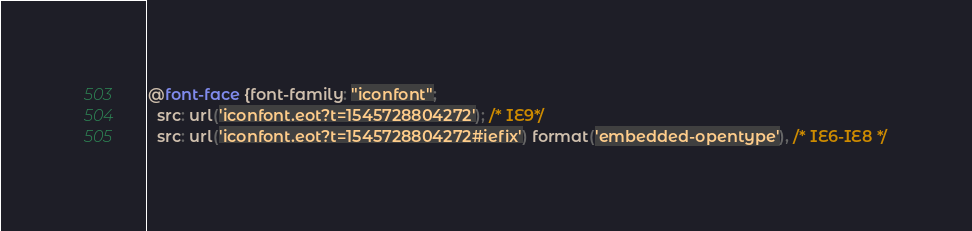<code> <loc_0><loc_0><loc_500><loc_500><_CSS_>
@font-face {font-family: "iconfont";
  src: url('iconfont.eot?t=1545728804272'); /* IE9*/
  src: url('iconfont.eot?t=1545728804272#iefix') format('embedded-opentype'), /* IE6-IE8 */</code> 